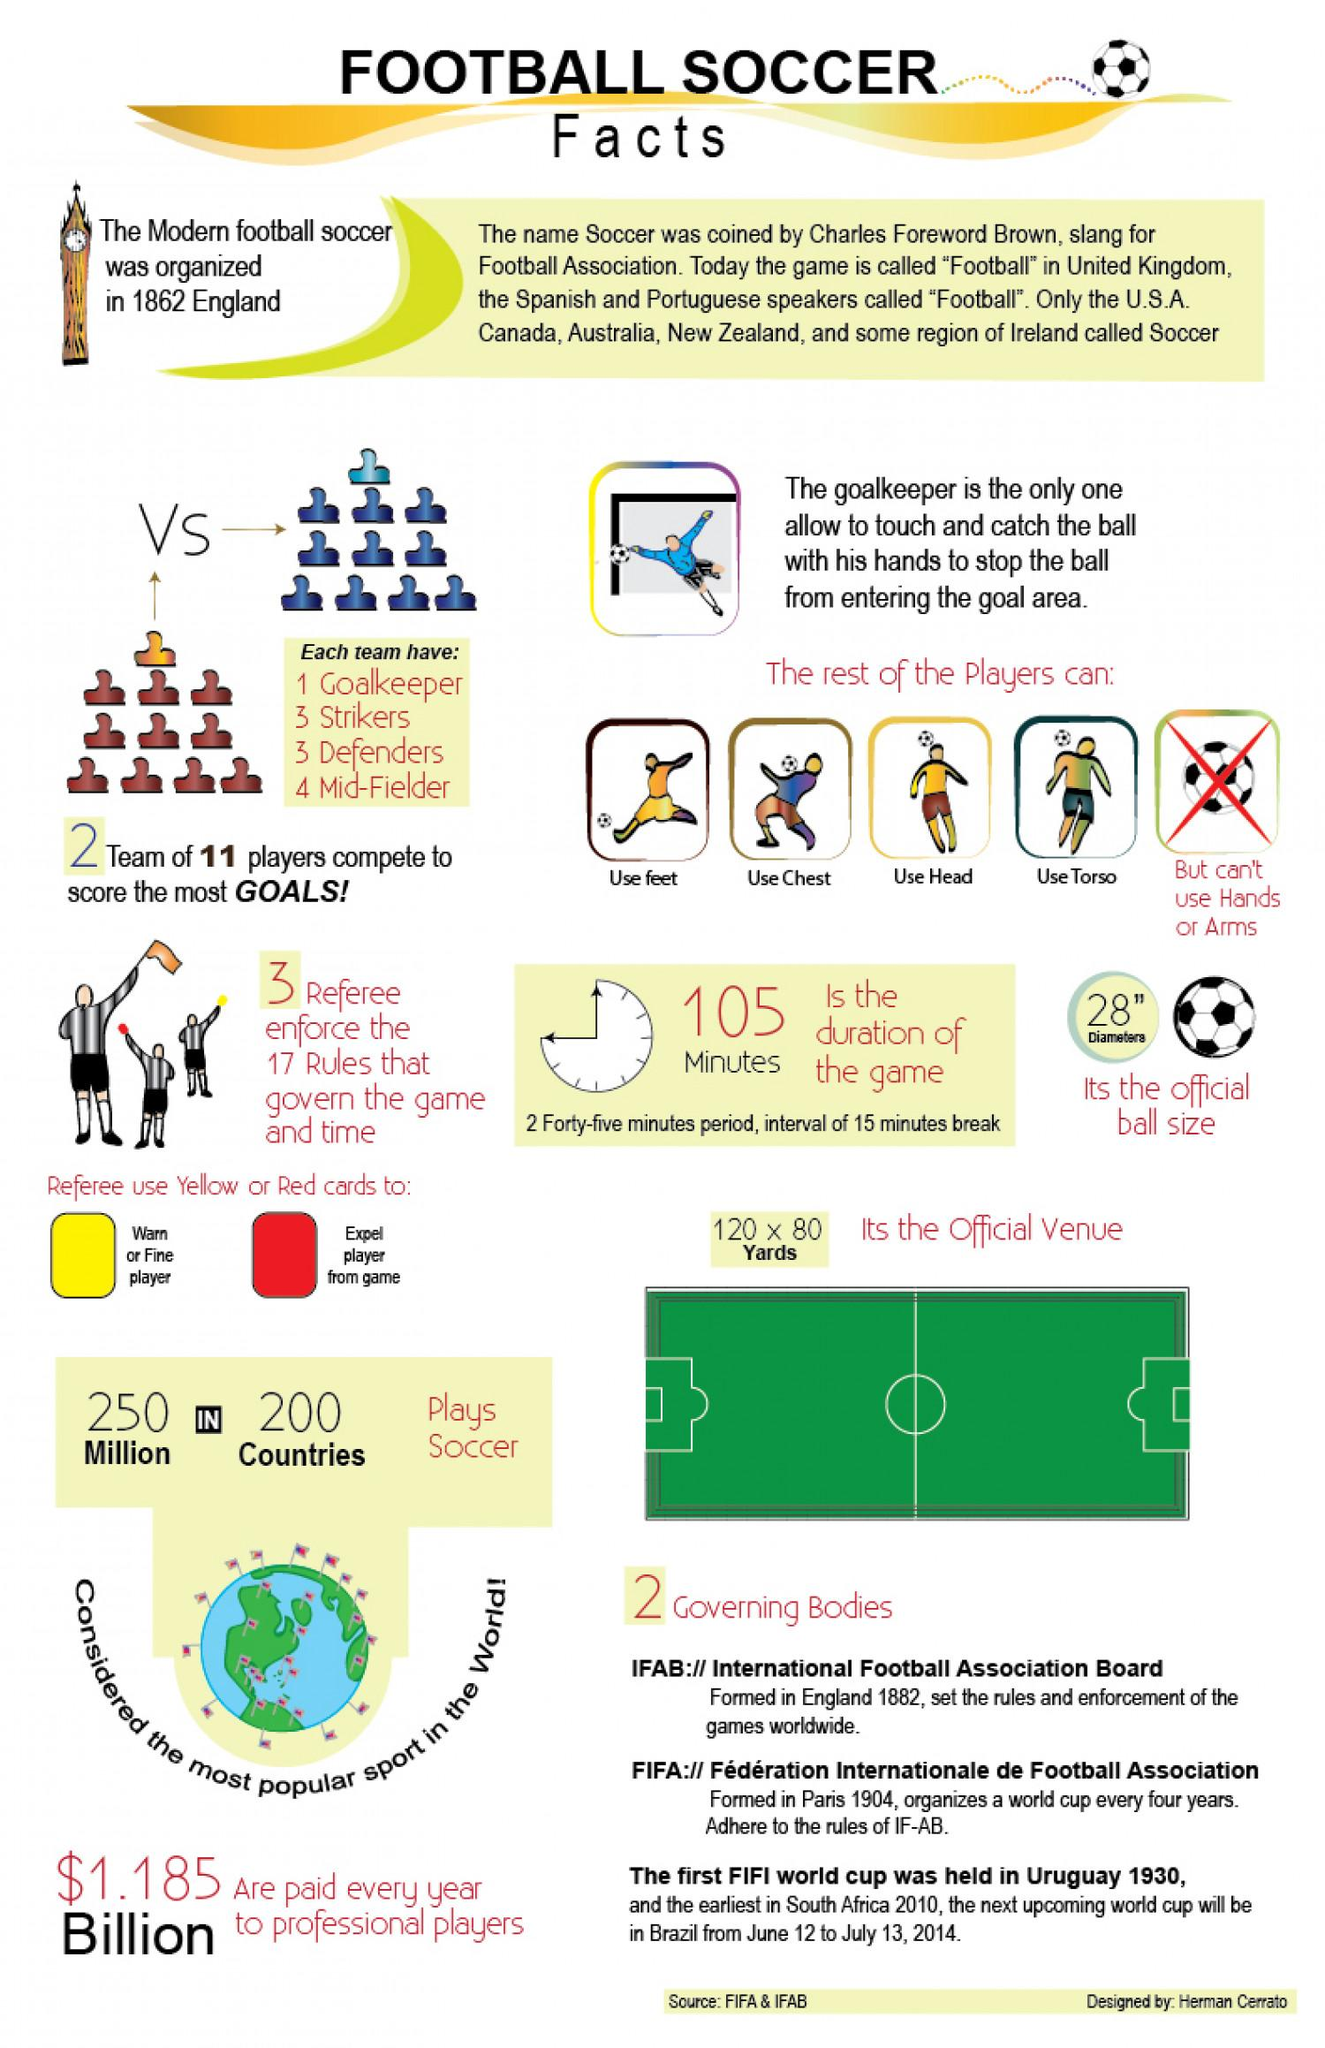Mention a couple of crucial points in this snapshot. Red color cards are used to expel players from the game. There are 8 footballs featured in this infographic. The color card that is used to warn a player is yellow. 